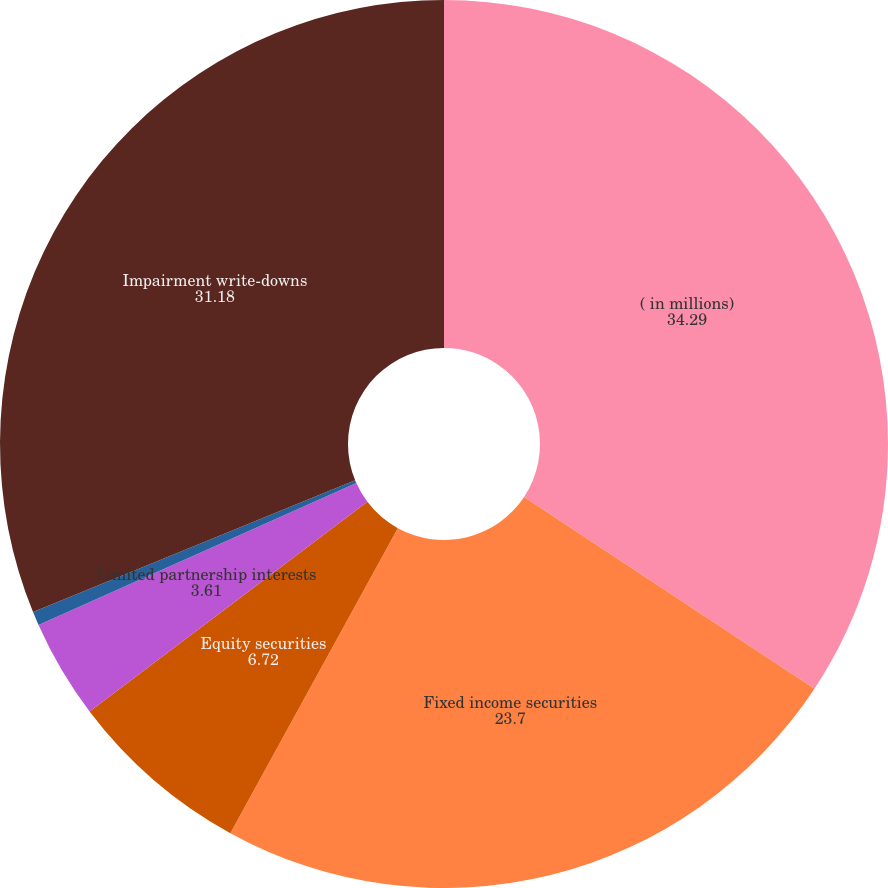Convert chart to OTSL. <chart><loc_0><loc_0><loc_500><loc_500><pie_chart><fcel>( in millions)<fcel>Fixed income securities<fcel>Equity securities<fcel>Limited partnership interests<fcel>Other investments<fcel>Impairment write-downs<nl><fcel>34.29%<fcel>23.7%<fcel>6.72%<fcel>3.61%<fcel>0.5%<fcel>31.18%<nl></chart> 